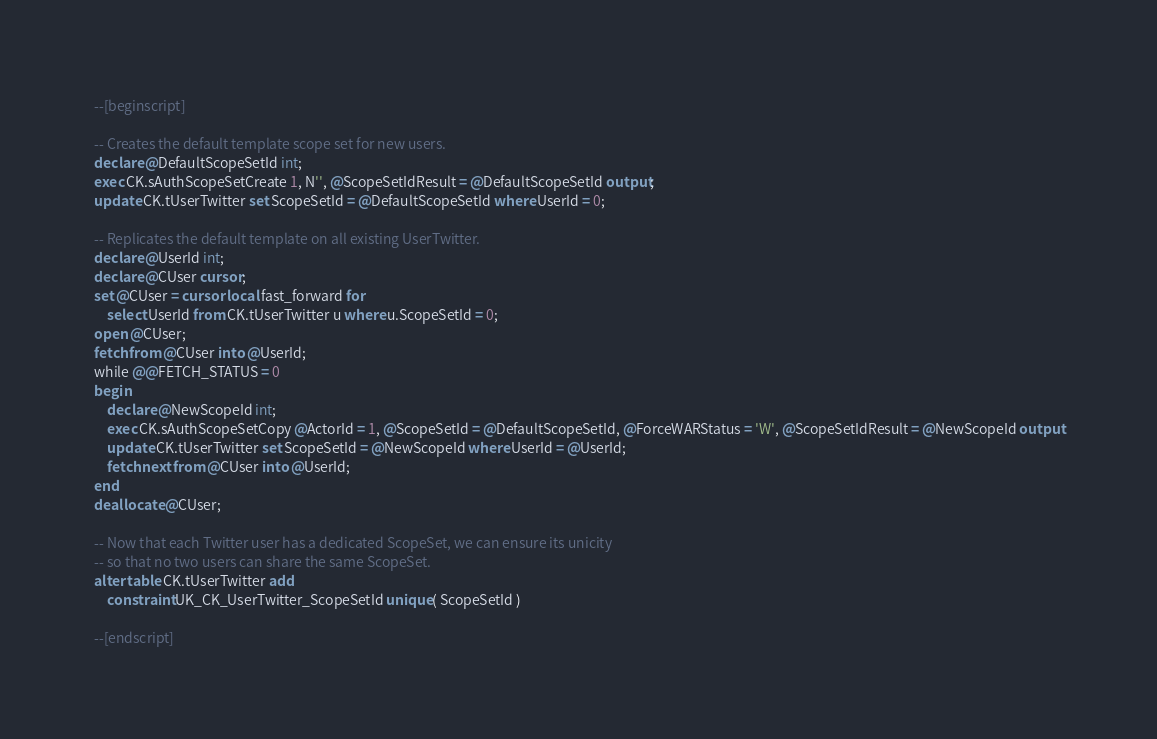Convert code to text. <code><loc_0><loc_0><loc_500><loc_500><_SQL_>--[beginscript]

-- Creates the default template scope set for new users.
declare @DefaultScopeSetId int;
exec CK.sAuthScopeSetCreate 1, N'', @ScopeSetIdResult = @DefaultScopeSetId output;
update CK.tUserTwitter set ScopeSetId = @DefaultScopeSetId where UserId = 0;

-- Replicates the default template on all existing UserTwitter.
declare @UserId int;
declare @CUser cursor;
set @CUser = cursor local fast_forward for 
	select UserId from CK.tUserTwitter u where u.ScopeSetId = 0;
open @CUser;
fetch from @CUser into @UserId;
while @@FETCH_STATUS = 0
begin
	declare @NewScopeId int;
	exec CK.sAuthScopeSetCopy @ActorId = 1, @ScopeSetId = @DefaultScopeSetId, @ForceWARStatus = 'W', @ScopeSetIdResult = @NewScopeId output
	update CK.tUserTwitter set ScopeSetId = @NewScopeId where UserId = @UserId;
	fetch next from @CUser into @UserId;
end
deallocate @CUser;

-- Now that each Twitter user has a dedicated ScopeSet, we can ensure its unicity
-- so that no two users can share the same ScopeSet.
alter table CK.tUserTwitter add
	constraint UK_CK_UserTwitter_ScopeSetId unique( ScopeSetId )

--[endscript]
</code> 